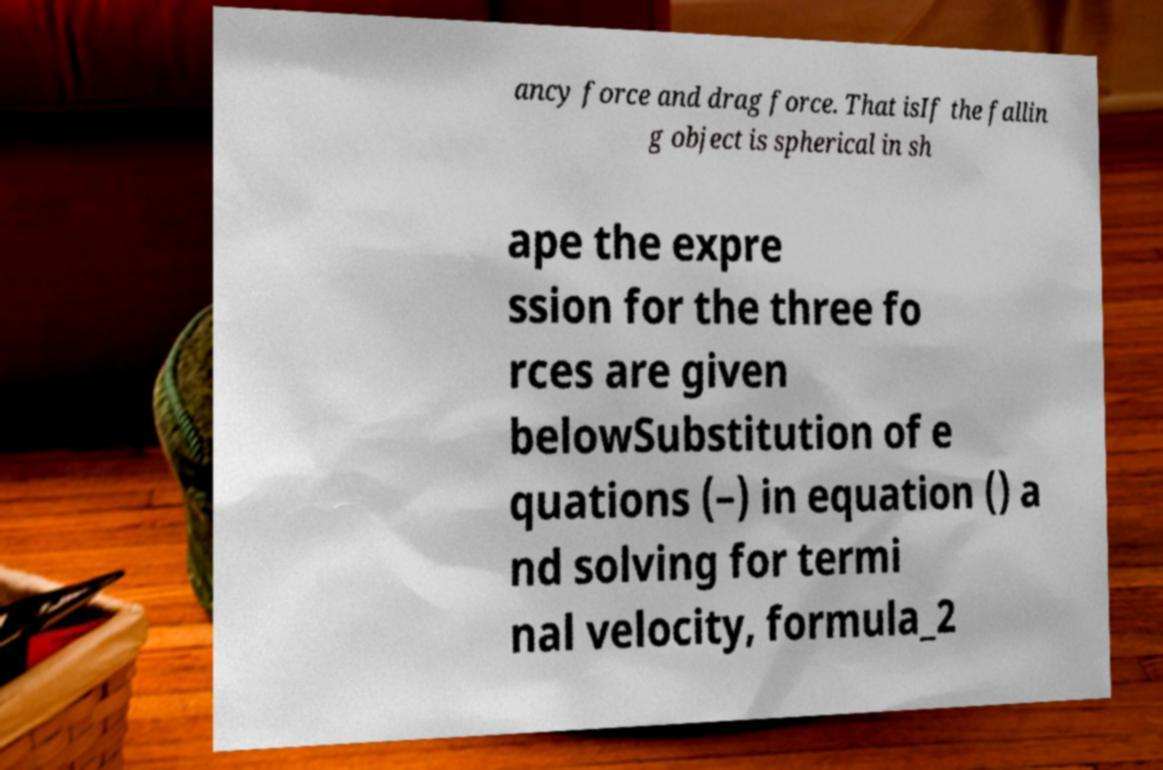Can you read and provide the text displayed in the image?This photo seems to have some interesting text. Can you extract and type it out for me? ancy force and drag force. That isIf the fallin g object is spherical in sh ape the expre ssion for the three fo rces are given belowSubstitution of e quations (–) in equation () a nd solving for termi nal velocity, formula_2 